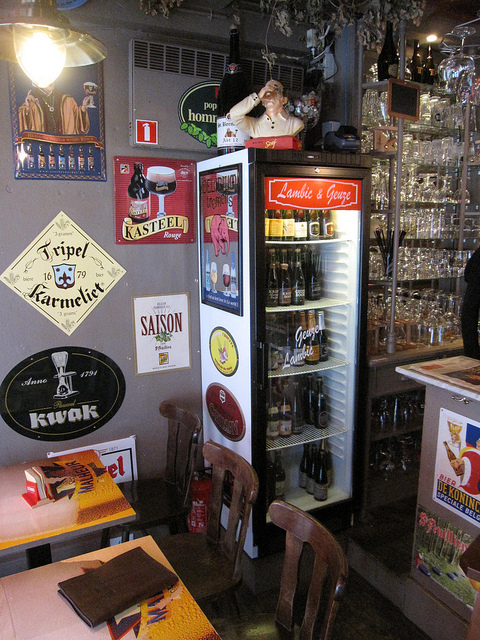Can you tell me something about the items on top of the refrigerator? On top of the refrigerator, there's a charming display that includes a small figurine, possibly a mascot or character related to one of the beer brands. Next to it, there are glasses strategically arranged, likely meant for serving various types of beer available in the fridge beneath. 